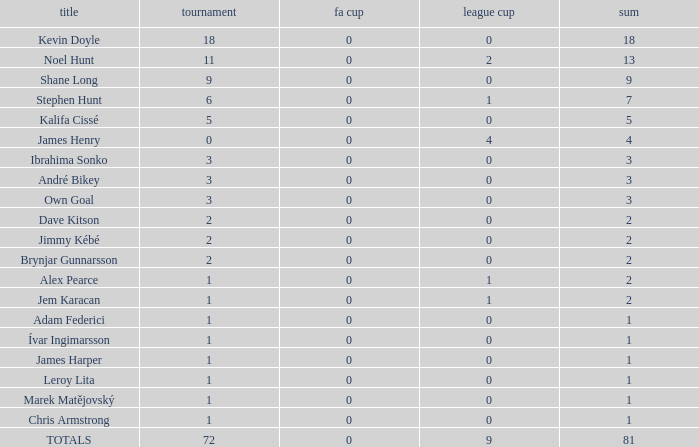What is the total championships that the league cup is less than 0? None. Write the full table. {'header': ['title', 'tournament', 'fa cup', 'league cup', 'sum'], 'rows': [['Kevin Doyle', '18', '0', '0', '18'], ['Noel Hunt', '11', '0', '2', '13'], ['Shane Long', '9', '0', '0', '9'], ['Stephen Hunt', '6', '0', '1', '7'], ['Kalifa Cissé', '5', '0', '0', '5'], ['James Henry', '0', '0', '4', '4'], ['Ibrahima Sonko', '3', '0', '0', '3'], ['André Bikey', '3', '0', '0', '3'], ['Own Goal', '3', '0', '0', '3'], ['Dave Kitson', '2', '0', '0', '2'], ['Jimmy Kébé', '2', '0', '0', '2'], ['Brynjar Gunnarsson', '2', '0', '0', '2'], ['Alex Pearce', '1', '0', '1', '2'], ['Jem Karacan', '1', '0', '1', '2'], ['Adam Federici', '1', '0', '0', '1'], ['Ívar Ingimarsson', '1', '0', '0', '1'], ['James Harper', '1', '0', '0', '1'], ['Leroy Lita', '1', '0', '0', '1'], ['Marek Matějovský', '1', '0', '0', '1'], ['Chris Armstrong', '1', '0', '0', '1'], ['TOTALS', '72', '0', '9', '81']]} 